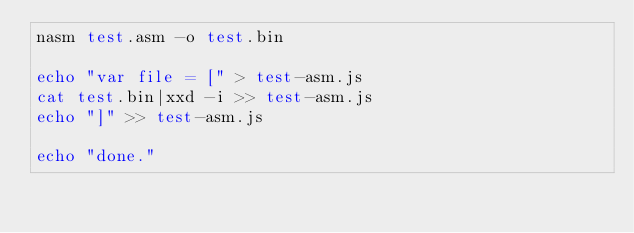Convert code to text. <code><loc_0><loc_0><loc_500><loc_500><_Bash_>nasm test.asm -o test.bin

echo "var file = [" > test-asm.js
cat test.bin|xxd -i >> test-asm.js
echo "]" >> test-asm.js

echo "done."

</code> 